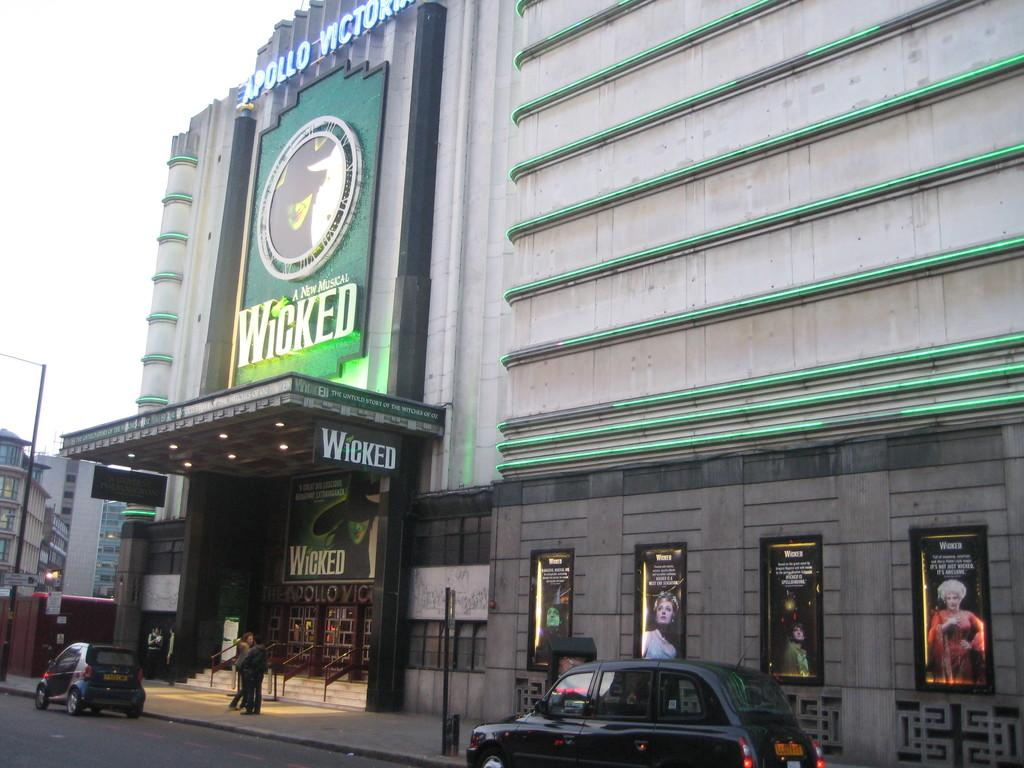<image>
Share a concise interpretation of the image provided. an ad for a play called Wicked on the theatre 